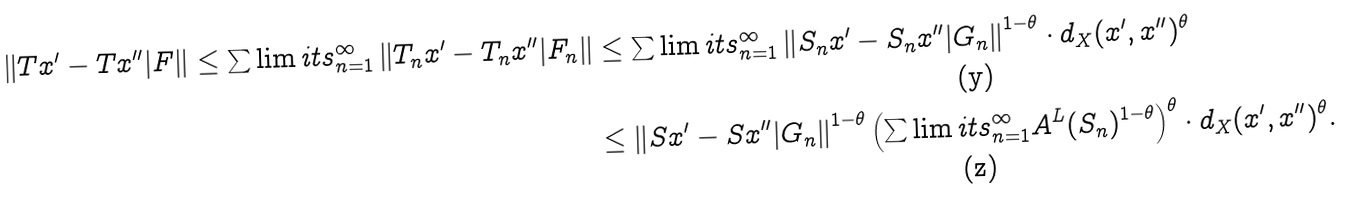<formula> <loc_0><loc_0><loc_500><loc_500>\left \| T x ^ { \prime } - T x ^ { \prime \prime } | F \right \| \leq \sum \lim i t s _ { n = 1 } ^ { \infty } \left \| T _ { n } x ^ { \prime } - T _ { n } x ^ { \prime \prime } | F _ { n } \right \| & \leq \sum \lim i t s _ { n = 1 } ^ { \infty } \left \| S _ { n } x ^ { \prime } - S _ { n } x ^ { \prime \prime } | G _ { n } \right \| ^ { 1 - \theta } \cdot d _ { X } ( x ^ { \prime } , x ^ { \prime \prime } ) ^ { \theta } \\ & \leq \left \| S x ^ { \prime } - S x ^ { \prime \prime } | G _ { n } \right \| ^ { 1 - \theta } \left ( \sum \lim i t s _ { n = 1 } ^ { \infty } A ^ { L } ( S _ { n } ) ^ { 1 - \theta } \right ) ^ { \theta } \cdot d _ { X } ( x ^ { \prime } , x ^ { \prime \prime } ) ^ { \theta } .</formula> 